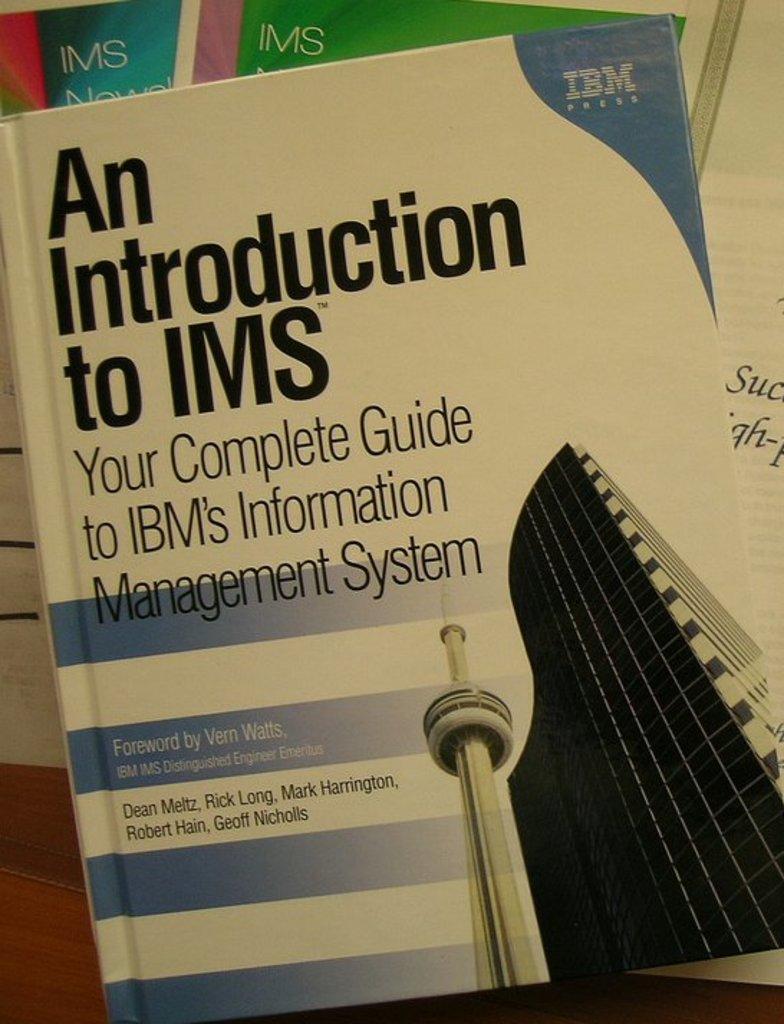Please provide a concise description of this image. In this picture I can see there is a book and there is something written on the cover page and there is a image of a building and there is a logo. There are few books placed on the wooden surface. 